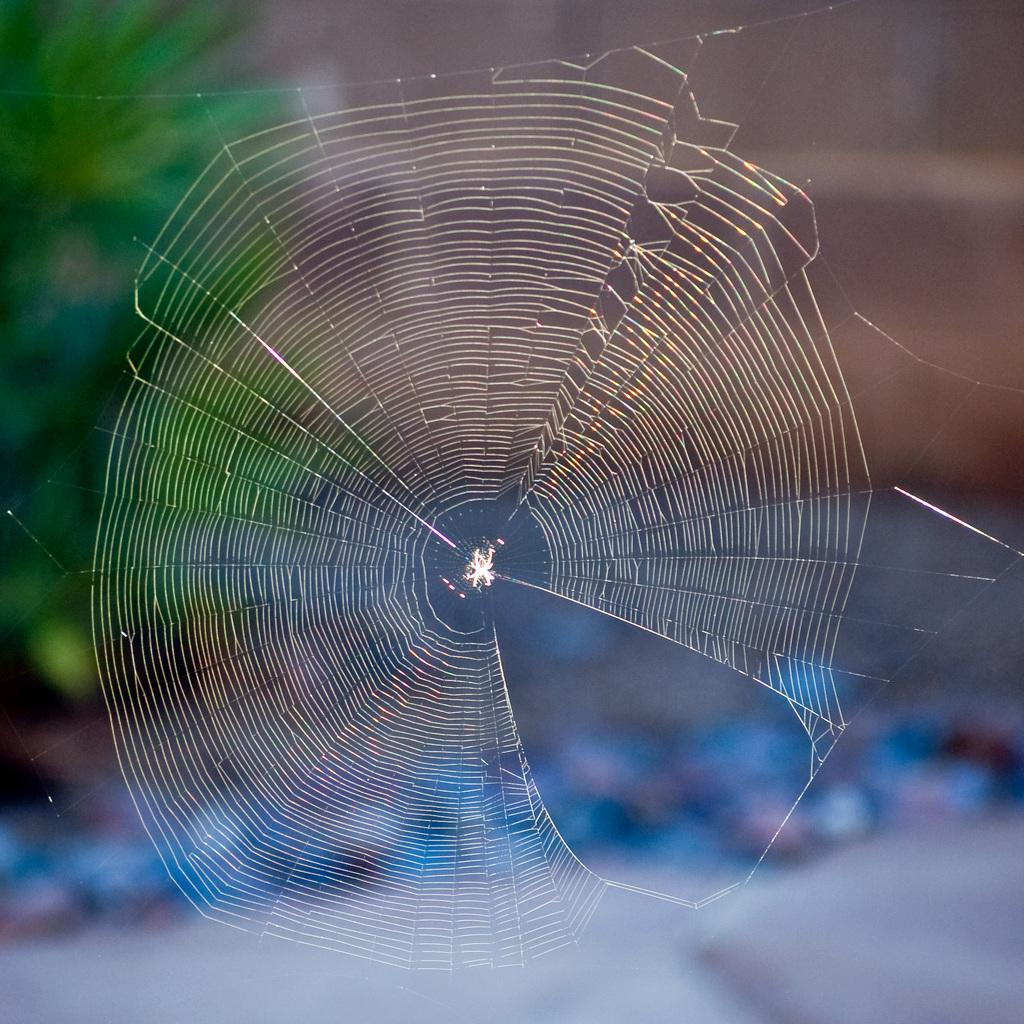What is the person in the picture holding? The person is holding an umbrella. Is there any specific weather condition in the image? Yes, it is raining in the picture. Where is the basketball located in the image? There is no basketball present in the image. Is the person in the image folding something? The image does not show the person folding anything. 